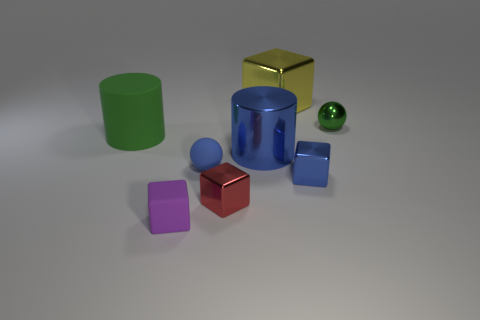Subtract 2 cubes. How many cubes are left? 2 Subtract all red cubes. How many cubes are left? 3 Subtract all purple blocks. How many blocks are left? 3 Subtract all gray blocks. Subtract all gray cylinders. How many blocks are left? 4 Add 2 gray cubes. How many objects exist? 10 Subtract all spheres. How many objects are left? 6 Subtract 1 red cubes. How many objects are left? 7 Subtract all rubber cylinders. Subtract all big blue metal cylinders. How many objects are left? 6 Add 2 tiny red blocks. How many tiny red blocks are left? 3 Add 5 small purple rubber things. How many small purple rubber things exist? 6 